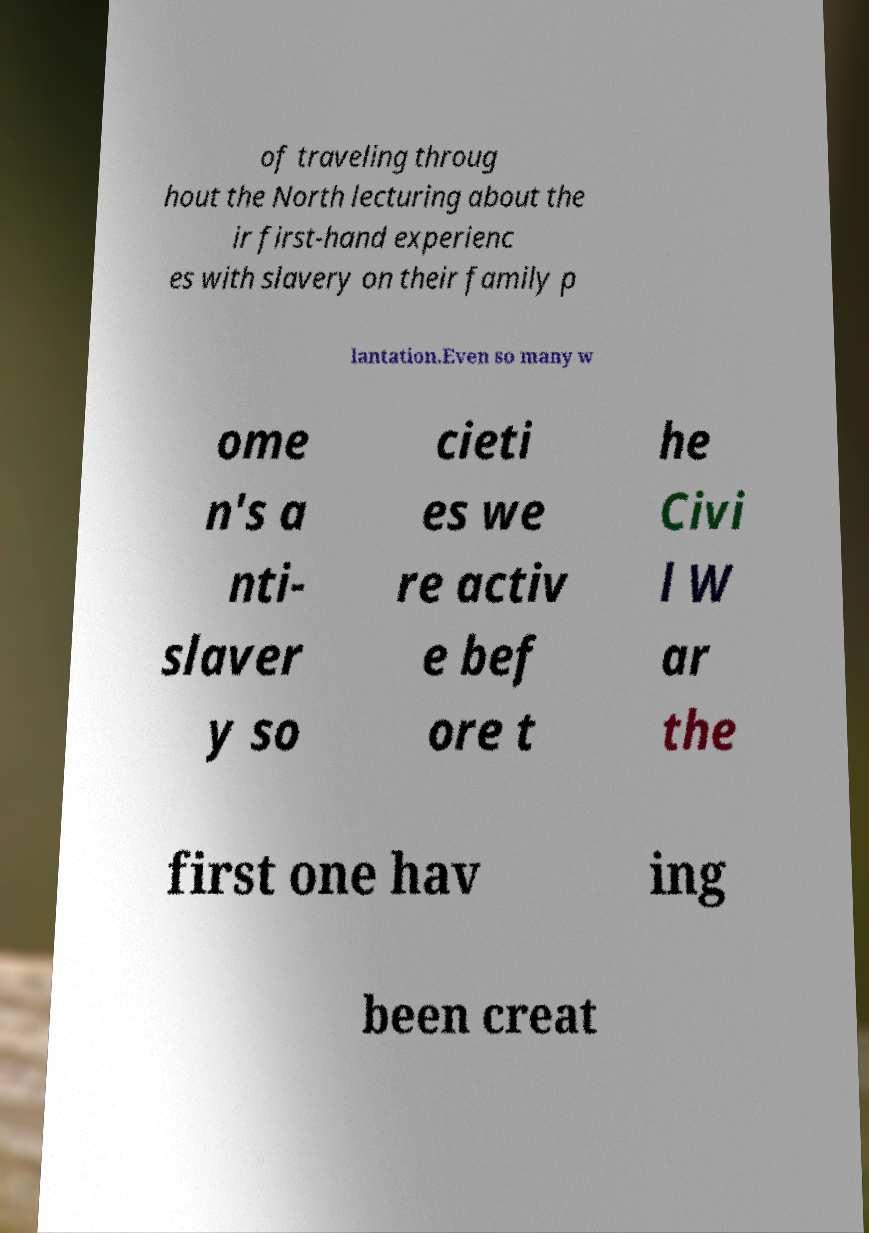There's text embedded in this image that I need extracted. Can you transcribe it verbatim? of traveling throug hout the North lecturing about the ir first-hand experienc es with slavery on their family p lantation.Even so many w ome n's a nti- slaver y so cieti es we re activ e bef ore t he Civi l W ar the first one hav ing been creat 